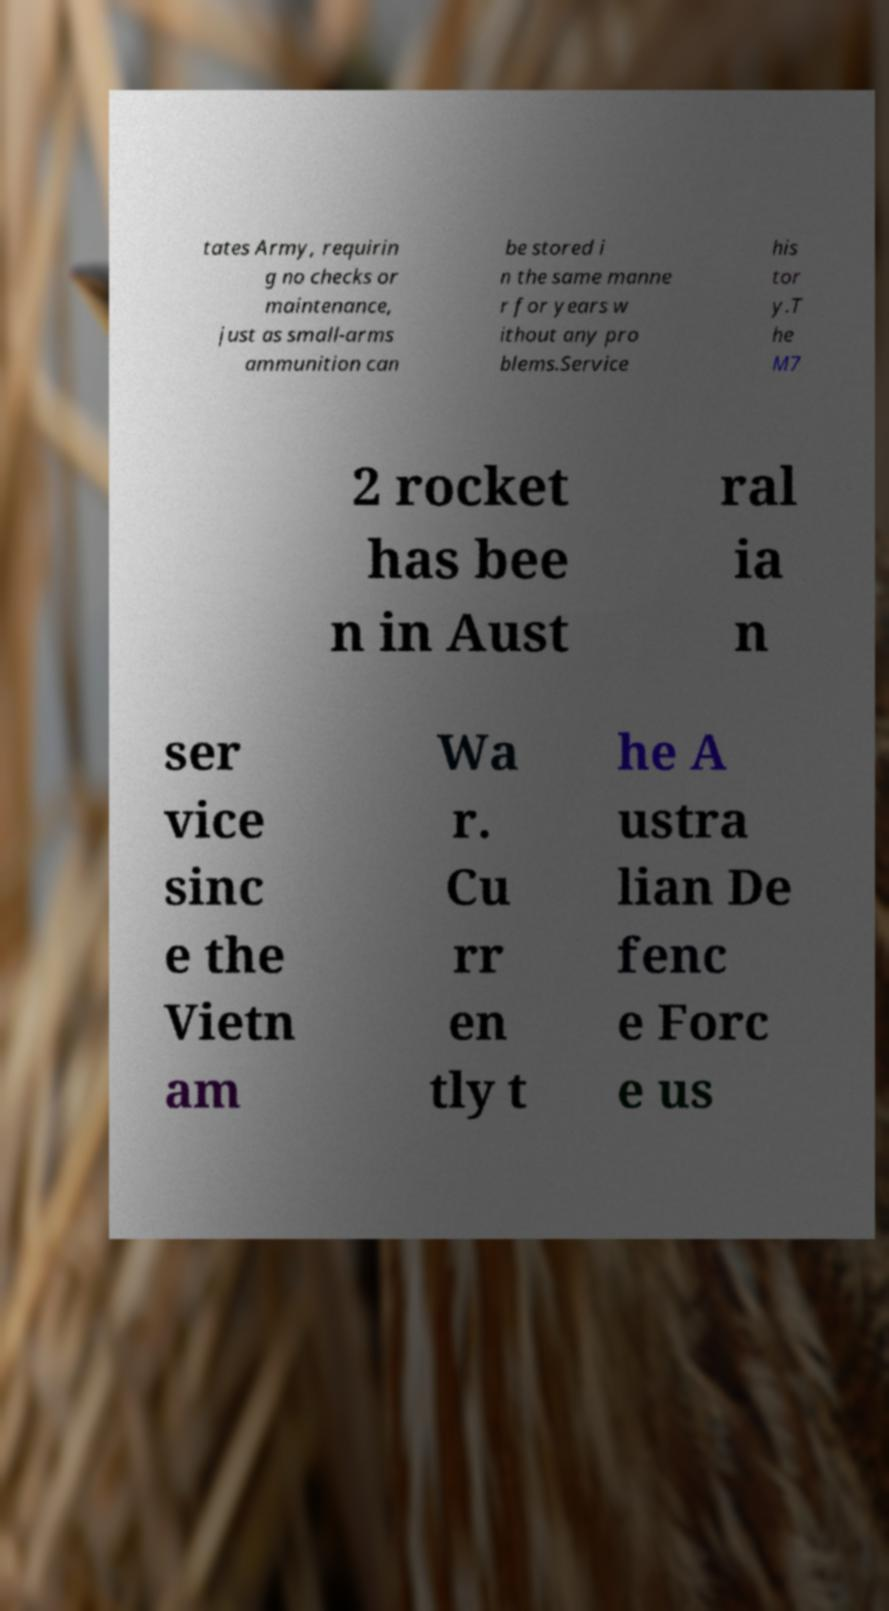Could you assist in decoding the text presented in this image and type it out clearly? tates Army, requirin g no checks or maintenance, just as small-arms ammunition can be stored i n the same manne r for years w ithout any pro blems.Service his tor y.T he M7 2 rocket has bee n in Aust ral ia n ser vice sinc e the Vietn am Wa r. Cu rr en tly t he A ustra lian De fenc e Forc e us 